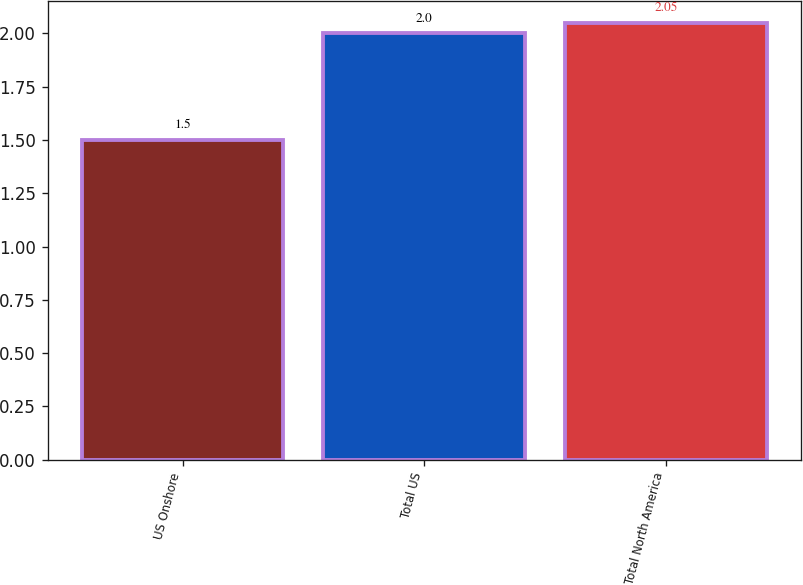Convert chart to OTSL. <chart><loc_0><loc_0><loc_500><loc_500><bar_chart><fcel>US Onshore<fcel>Total US<fcel>Total North America<nl><fcel>1.5<fcel>2<fcel>2.05<nl></chart> 